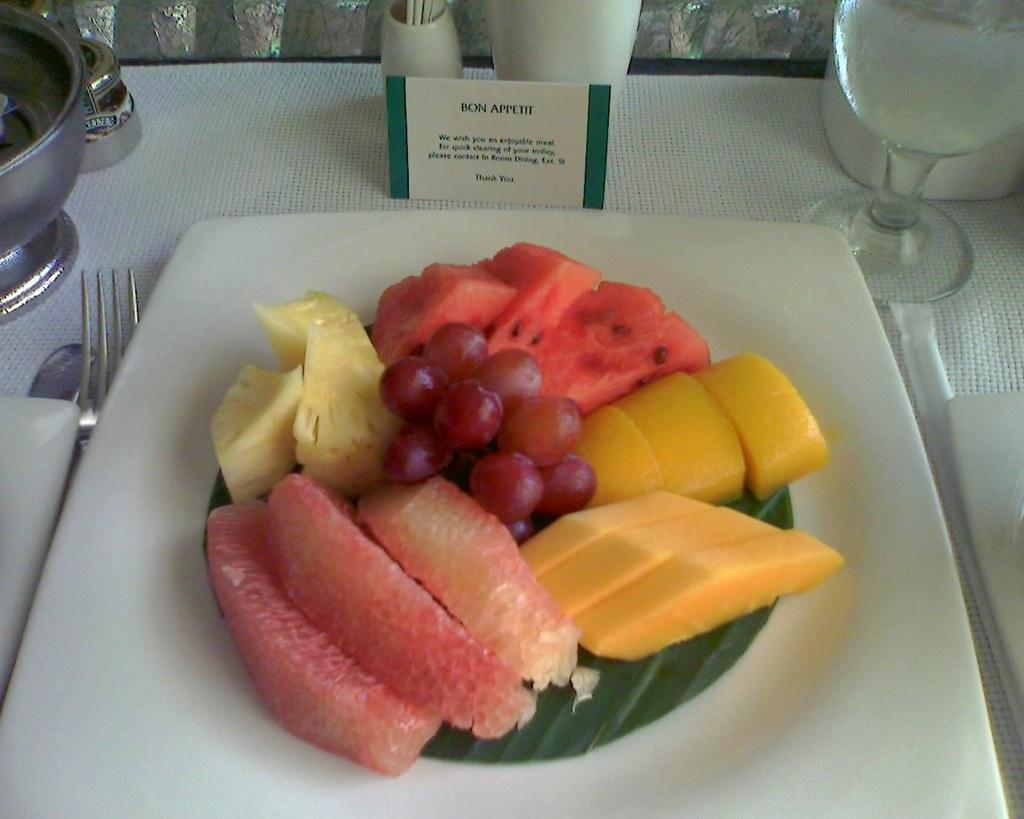What type of food is on the plate in the image? There are fruits on a plate in the image. What is located beside the plate in the image? There is a glass beside the plate in the image. What utensil can be seen in the image? There is a fork in the image. What type of paper item is present in the image? There is a card in the image. What other objects are on the table in the image? There are other objects on the table in the image. What type of thread is being used to embark on a voyage in the image? There is no thread or voyage present in the image. What type of letter is being written on the table in the image? There is no letter being written in the image; only a card and other objects are present on the table. 